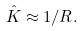<formula> <loc_0><loc_0><loc_500><loc_500>\hat { K } \approx 1 / R .</formula> 